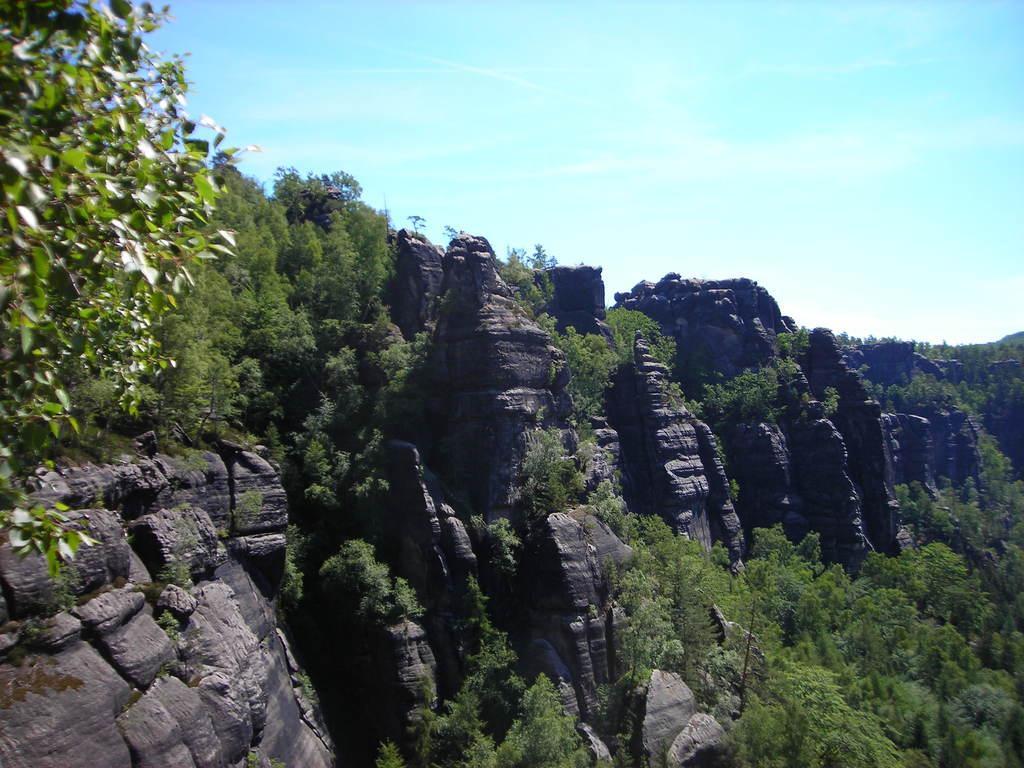In one or two sentences, can you explain what this image depicts? In the image there are huge hills and in between the hills there are many plants. 